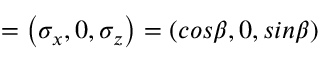Convert formula to latex. <formula><loc_0><loc_0><loc_500><loc_500>{ \sigma } = \left ( { \sigma } _ { x } , 0 , { \sigma } _ { z } \right ) = \left ( { \cos } \beta , 0 , { \sin } \beta \right )</formula> 